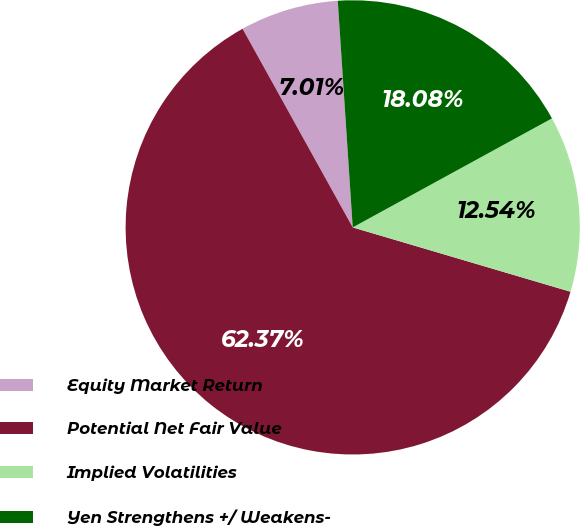Convert chart to OTSL. <chart><loc_0><loc_0><loc_500><loc_500><pie_chart><fcel>Equity Market Return<fcel>Potential Net Fair Value<fcel>Implied Volatilities<fcel>Yen Strengthens +/ Weakens-<nl><fcel>7.01%<fcel>62.37%<fcel>12.54%<fcel>18.08%<nl></chart> 